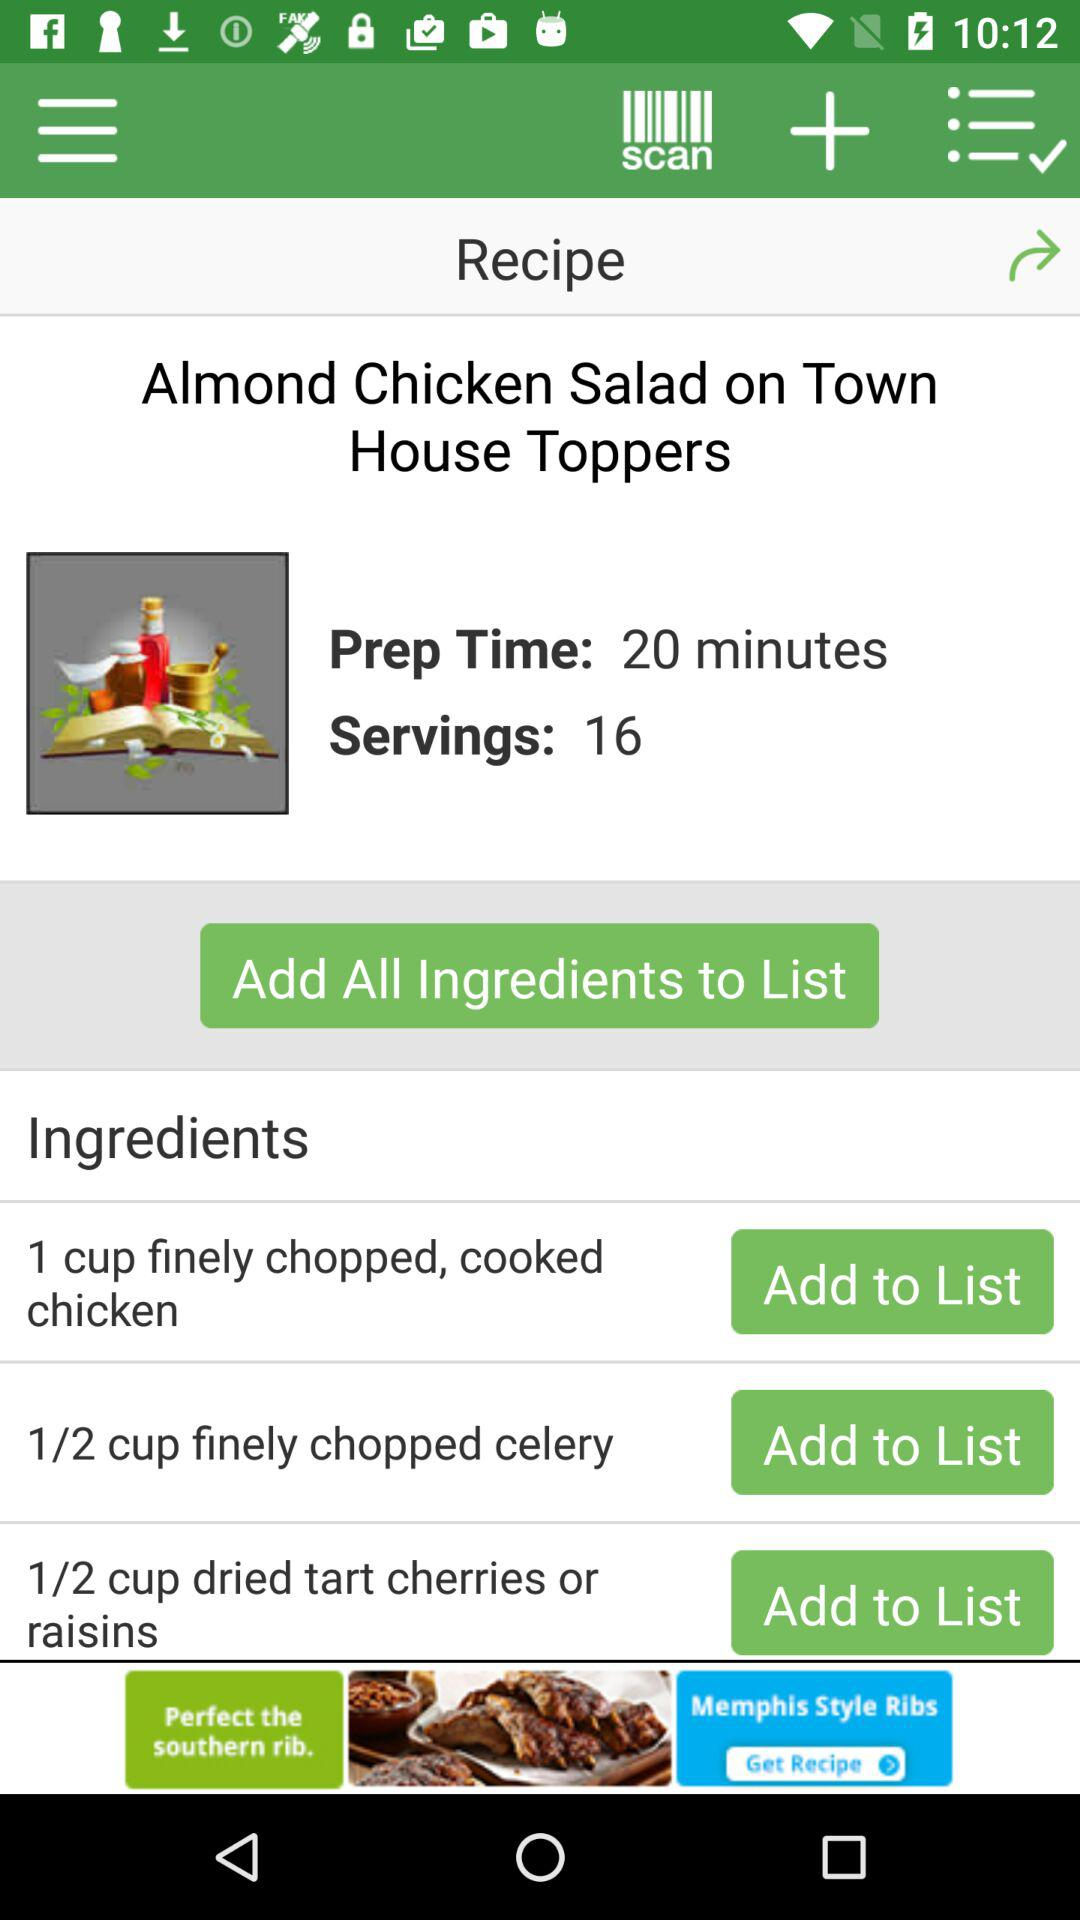How many ingredients are there in this recipe?
Answer the question using a single word or phrase. 3 